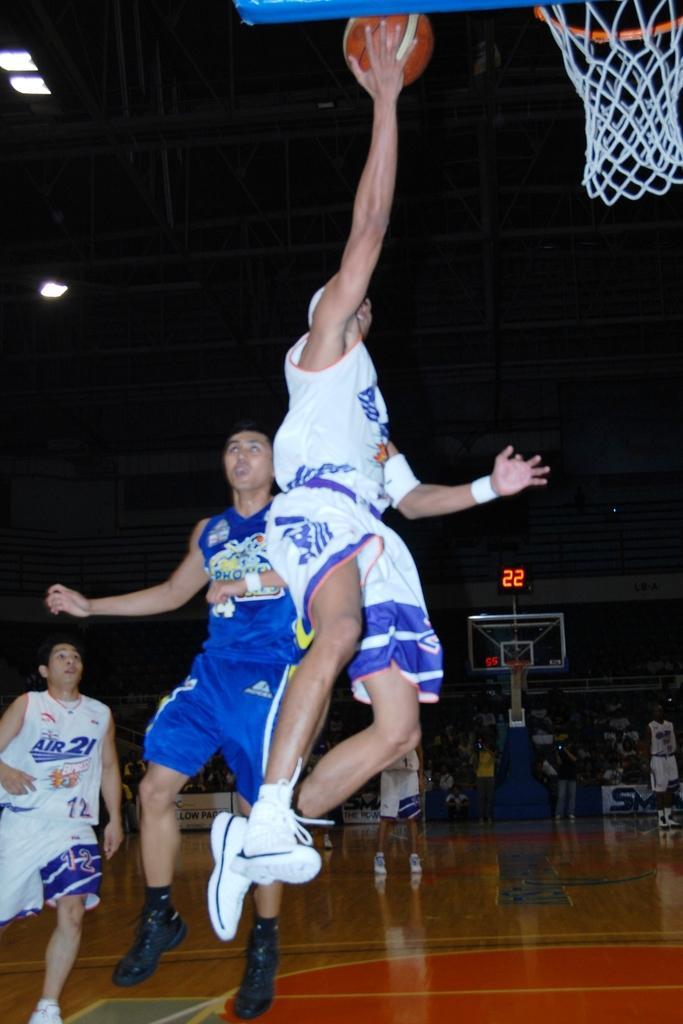Provide a one-sentence caption for the provided image. A basketball player for the Air 21 team goes for a basket. 